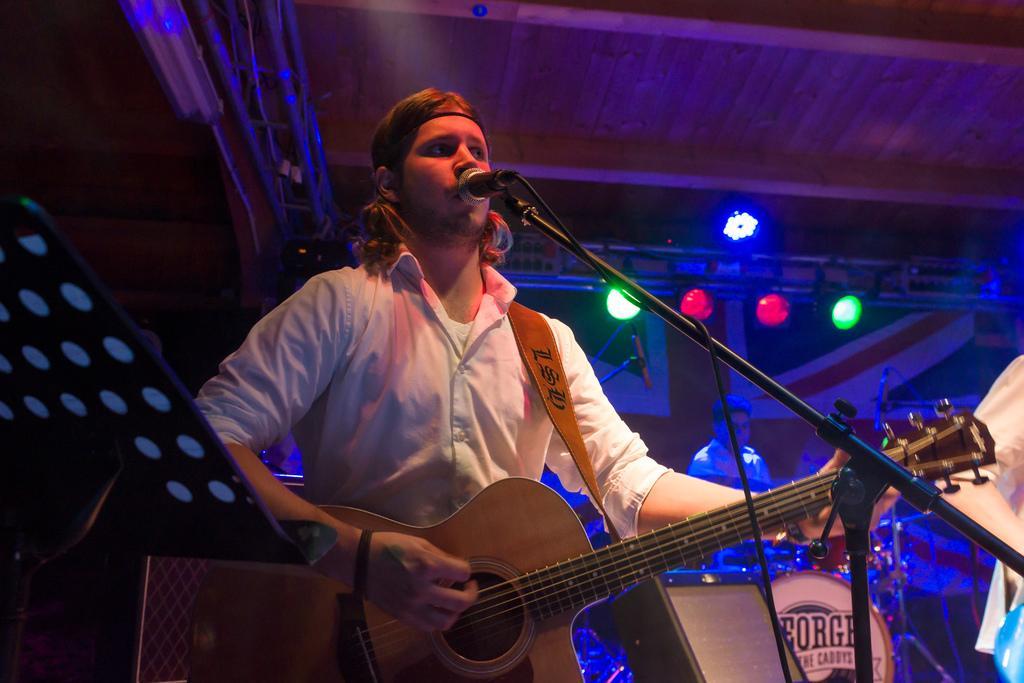Can you describe this image briefly? In this picture we can see man standing holding guitar in his hand and playing it and singing on mic and beside to him we can see person playing drums and other person standing and in background we can see green and red color lights, wall. 